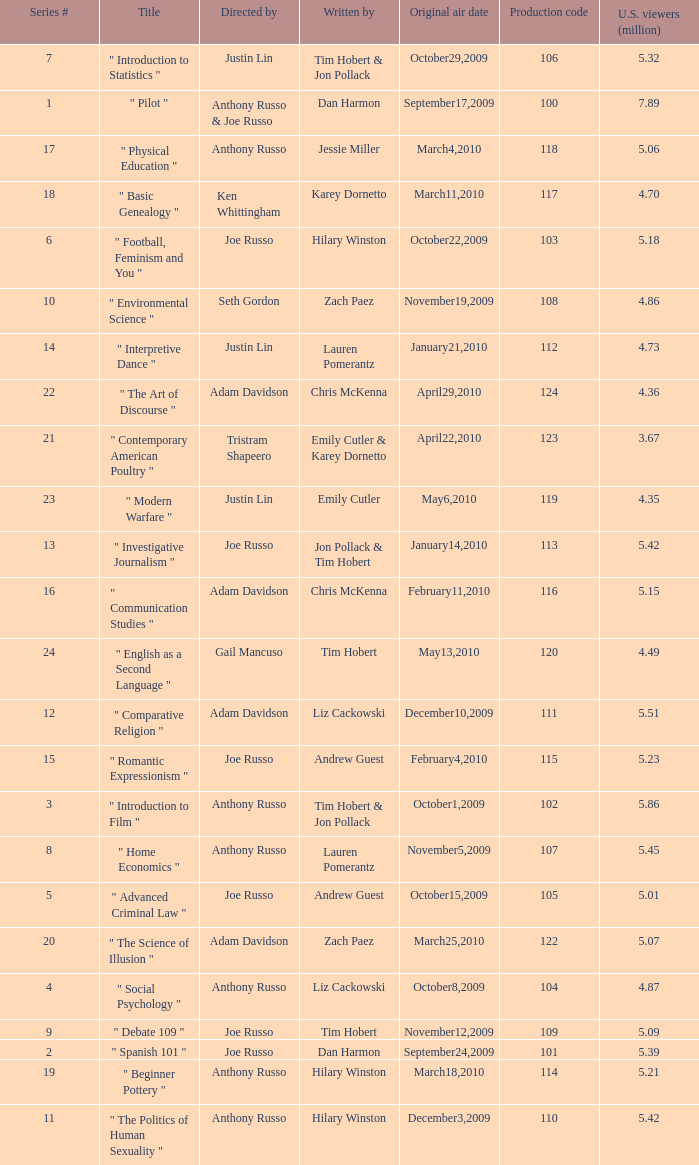Parse the full table. {'header': ['Series #', 'Title', 'Directed by', 'Written by', 'Original air date', 'Production code', 'U.S. viewers (million)'], 'rows': [['7', '" Introduction to Statistics "', 'Justin Lin', 'Tim Hobert & Jon Pollack', 'October29,2009', '106', '5.32'], ['1', '" Pilot "', 'Anthony Russo & Joe Russo', 'Dan Harmon', 'September17,2009', '100', '7.89'], ['17', '" Physical Education "', 'Anthony Russo', 'Jessie Miller', 'March4,2010', '118', '5.06'], ['18', '" Basic Genealogy "', 'Ken Whittingham', 'Karey Dornetto', 'March11,2010', '117', '4.70'], ['6', '" Football, Feminism and You "', 'Joe Russo', 'Hilary Winston', 'October22,2009', '103', '5.18'], ['10', '" Environmental Science "', 'Seth Gordon', 'Zach Paez', 'November19,2009', '108', '4.86'], ['14', '" Interpretive Dance "', 'Justin Lin', 'Lauren Pomerantz', 'January21,2010', '112', '4.73'], ['22', '" The Art of Discourse "', 'Adam Davidson', 'Chris McKenna', 'April29,2010', '124', '4.36'], ['21', '" Contemporary American Poultry "', 'Tristram Shapeero', 'Emily Cutler & Karey Dornetto', 'April22,2010', '123', '3.67'], ['23', '" Modern Warfare "', 'Justin Lin', 'Emily Cutler', 'May6,2010', '119', '4.35'], ['13', '" Investigative Journalism "', 'Joe Russo', 'Jon Pollack & Tim Hobert', 'January14,2010', '113', '5.42'], ['16', '" Communication Studies "', 'Adam Davidson', 'Chris McKenna', 'February11,2010', '116', '5.15'], ['24', '" English as a Second Language "', 'Gail Mancuso', 'Tim Hobert', 'May13,2010', '120', '4.49'], ['12', '" Comparative Religion "', 'Adam Davidson', 'Liz Cackowski', 'December10,2009', '111', '5.51'], ['15', '" Romantic Expressionism "', 'Joe Russo', 'Andrew Guest', 'February4,2010', '115', '5.23'], ['3', '" Introduction to Film "', 'Anthony Russo', 'Tim Hobert & Jon Pollack', 'October1,2009', '102', '5.86'], ['8', '" Home Economics "', 'Anthony Russo', 'Lauren Pomerantz', 'November5,2009', '107', '5.45'], ['5', '" Advanced Criminal Law "', 'Joe Russo', 'Andrew Guest', 'October15,2009', '105', '5.01'], ['20', '" The Science of Illusion "', 'Adam Davidson', 'Zach Paez', 'March25,2010', '122', '5.07'], ['4', '" Social Psychology "', 'Anthony Russo', 'Liz Cackowski', 'October8,2009', '104', '4.87'], ['9', '" Debate 109 "', 'Joe Russo', 'Tim Hobert', 'November12,2009', '109', '5.09'], ['2', '" Spanish 101 "', 'Joe Russo', 'Dan Harmon', 'September24,2009', '101', '5.39'], ['19', '" Beginner Pottery "', 'Anthony Russo', 'Hilary Winston', 'March18,2010', '114', '5.21'], ['11', '" The Politics of Human Sexuality "', 'Anthony Russo', 'Hilary Winston', 'December3,2009', '110', '5.42']]} What is the title of the series # 8? " Home Economics ". 